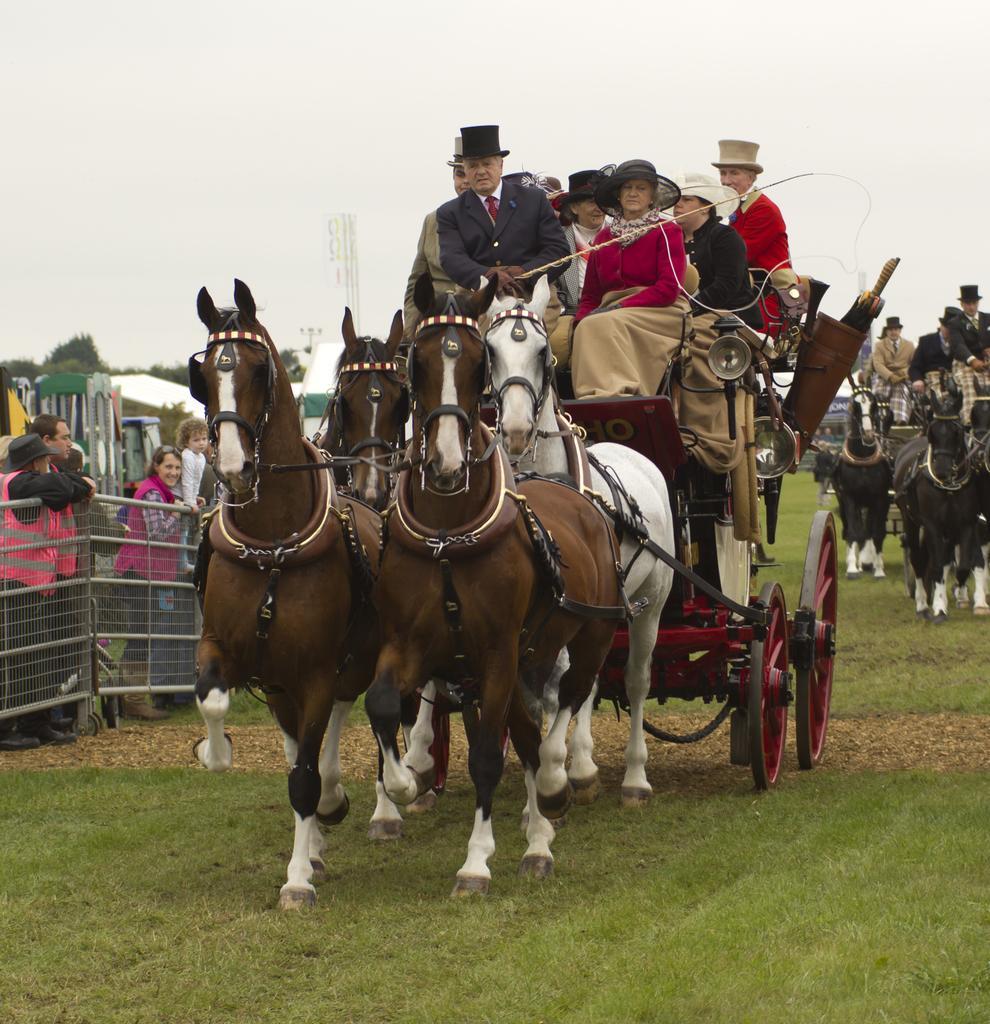Can you describe this image briefly? This is an outside view. In this image I can see few horse carts on which few people are sitting. At the bottom, I can see the grass on the ground. On the left side there is a fencing, behind few people are standing. In the background there are few trees. At the top of the image I can see the sky. 